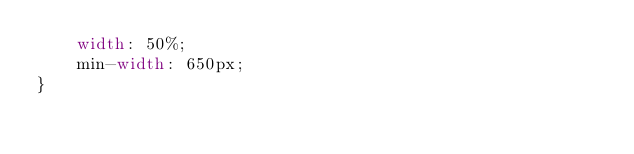<code> <loc_0><loc_0><loc_500><loc_500><_CSS_>    width: 50%;
    min-width: 650px;
}
</code> 